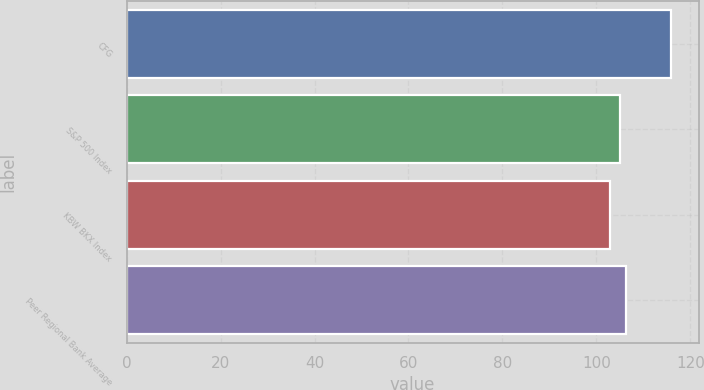Convert chart. <chart><loc_0><loc_0><loc_500><loc_500><bar_chart><fcel>CFG<fcel>S&P 500 Index<fcel>KBW BKX Index<fcel>Peer Regional Bank Average<nl><fcel>116<fcel>105<fcel>103<fcel>106.3<nl></chart> 